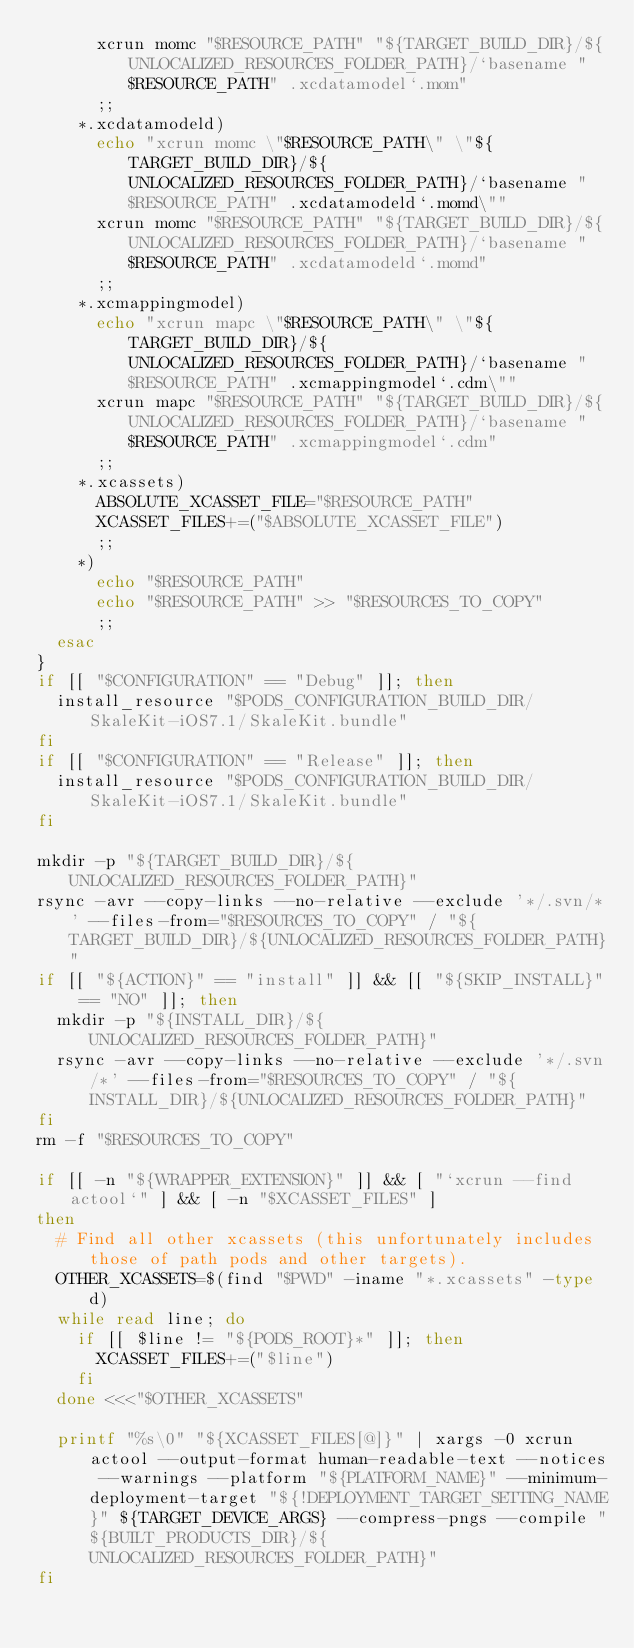Convert code to text. <code><loc_0><loc_0><loc_500><loc_500><_Bash_>      xcrun momc "$RESOURCE_PATH" "${TARGET_BUILD_DIR}/${UNLOCALIZED_RESOURCES_FOLDER_PATH}/`basename "$RESOURCE_PATH" .xcdatamodel`.mom"
      ;;
    *.xcdatamodeld)
      echo "xcrun momc \"$RESOURCE_PATH\" \"${TARGET_BUILD_DIR}/${UNLOCALIZED_RESOURCES_FOLDER_PATH}/`basename "$RESOURCE_PATH" .xcdatamodeld`.momd\""
      xcrun momc "$RESOURCE_PATH" "${TARGET_BUILD_DIR}/${UNLOCALIZED_RESOURCES_FOLDER_PATH}/`basename "$RESOURCE_PATH" .xcdatamodeld`.momd"
      ;;
    *.xcmappingmodel)
      echo "xcrun mapc \"$RESOURCE_PATH\" \"${TARGET_BUILD_DIR}/${UNLOCALIZED_RESOURCES_FOLDER_PATH}/`basename "$RESOURCE_PATH" .xcmappingmodel`.cdm\""
      xcrun mapc "$RESOURCE_PATH" "${TARGET_BUILD_DIR}/${UNLOCALIZED_RESOURCES_FOLDER_PATH}/`basename "$RESOURCE_PATH" .xcmappingmodel`.cdm"
      ;;
    *.xcassets)
      ABSOLUTE_XCASSET_FILE="$RESOURCE_PATH"
      XCASSET_FILES+=("$ABSOLUTE_XCASSET_FILE")
      ;;
    *)
      echo "$RESOURCE_PATH"
      echo "$RESOURCE_PATH" >> "$RESOURCES_TO_COPY"
      ;;
  esac
}
if [[ "$CONFIGURATION" == "Debug" ]]; then
  install_resource "$PODS_CONFIGURATION_BUILD_DIR/SkaleKit-iOS7.1/SkaleKit.bundle"
fi
if [[ "$CONFIGURATION" == "Release" ]]; then
  install_resource "$PODS_CONFIGURATION_BUILD_DIR/SkaleKit-iOS7.1/SkaleKit.bundle"
fi

mkdir -p "${TARGET_BUILD_DIR}/${UNLOCALIZED_RESOURCES_FOLDER_PATH}"
rsync -avr --copy-links --no-relative --exclude '*/.svn/*' --files-from="$RESOURCES_TO_COPY" / "${TARGET_BUILD_DIR}/${UNLOCALIZED_RESOURCES_FOLDER_PATH}"
if [[ "${ACTION}" == "install" ]] && [[ "${SKIP_INSTALL}" == "NO" ]]; then
  mkdir -p "${INSTALL_DIR}/${UNLOCALIZED_RESOURCES_FOLDER_PATH}"
  rsync -avr --copy-links --no-relative --exclude '*/.svn/*' --files-from="$RESOURCES_TO_COPY" / "${INSTALL_DIR}/${UNLOCALIZED_RESOURCES_FOLDER_PATH}"
fi
rm -f "$RESOURCES_TO_COPY"

if [[ -n "${WRAPPER_EXTENSION}" ]] && [ "`xcrun --find actool`" ] && [ -n "$XCASSET_FILES" ]
then
  # Find all other xcassets (this unfortunately includes those of path pods and other targets).
  OTHER_XCASSETS=$(find "$PWD" -iname "*.xcassets" -type d)
  while read line; do
    if [[ $line != "${PODS_ROOT}*" ]]; then
      XCASSET_FILES+=("$line")
    fi
  done <<<"$OTHER_XCASSETS"

  printf "%s\0" "${XCASSET_FILES[@]}" | xargs -0 xcrun actool --output-format human-readable-text --notices --warnings --platform "${PLATFORM_NAME}" --minimum-deployment-target "${!DEPLOYMENT_TARGET_SETTING_NAME}" ${TARGET_DEVICE_ARGS} --compress-pngs --compile "${BUILT_PRODUCTS_DIR}/${UNLOCALIZED_RESOURCES_FOLDER_PATH}"
fi
</code> 